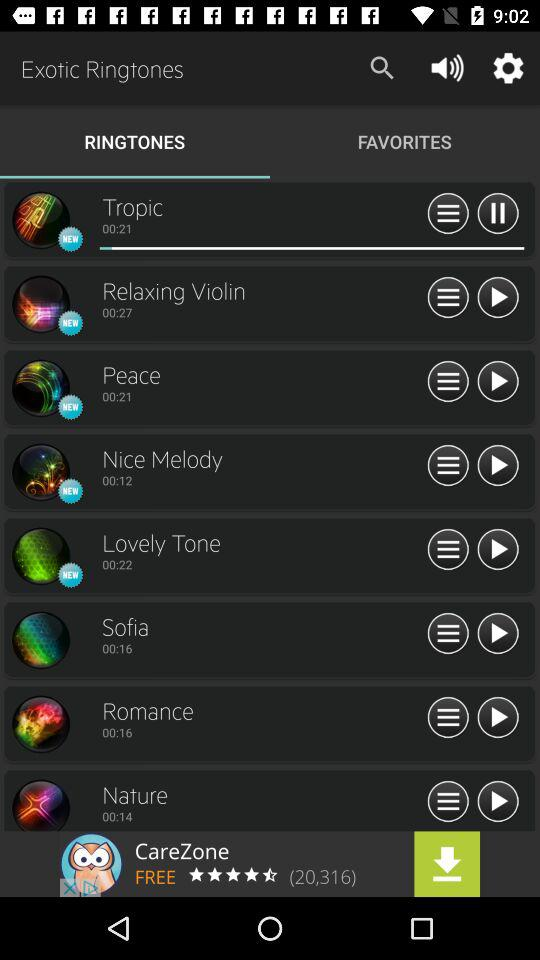What is the duration of the Nature ringtone? The duration is "00:14". 